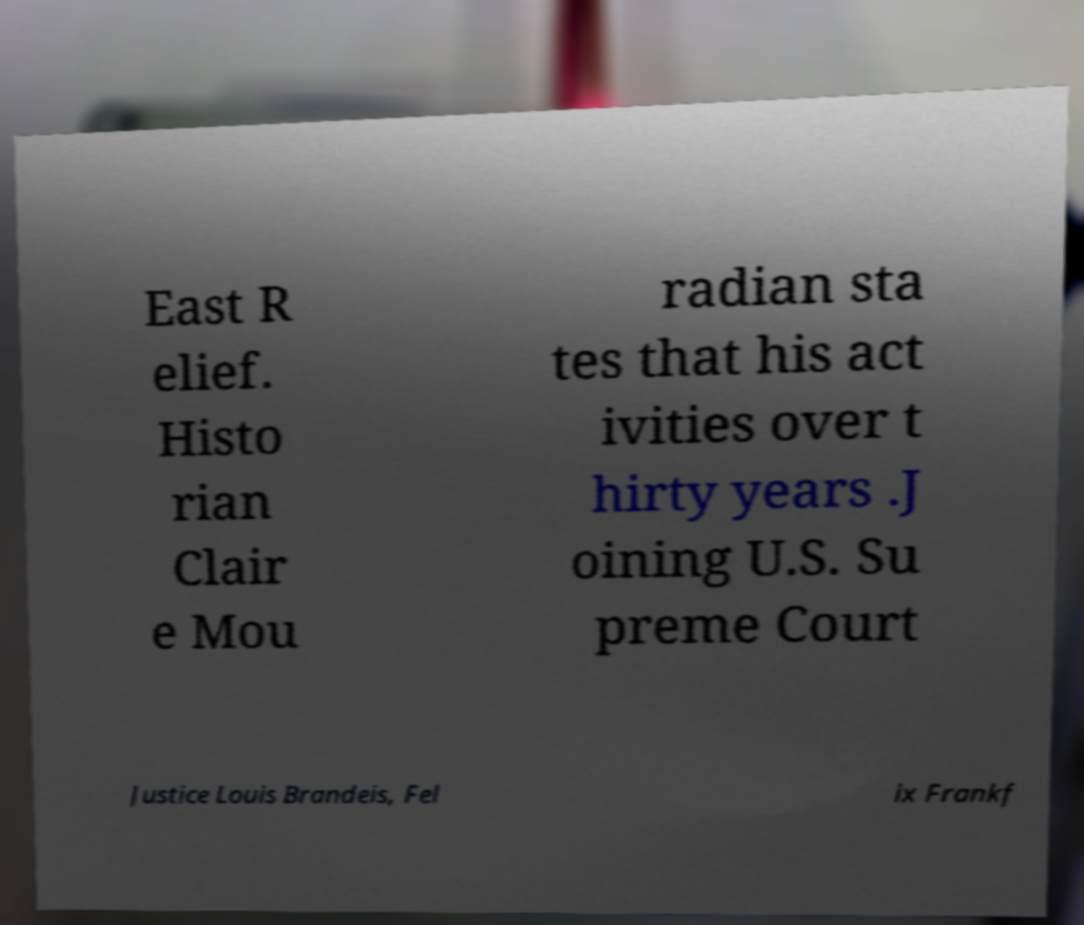What messages or text are displayed in this image? I need them in a readable, typed format. East R elief. Histo rian Clair e Mou radian sta tes that his act ivities over t hirty years .J oining U.S. Su preme Court Justice Louis Brandeis, Fel ix Frankf 